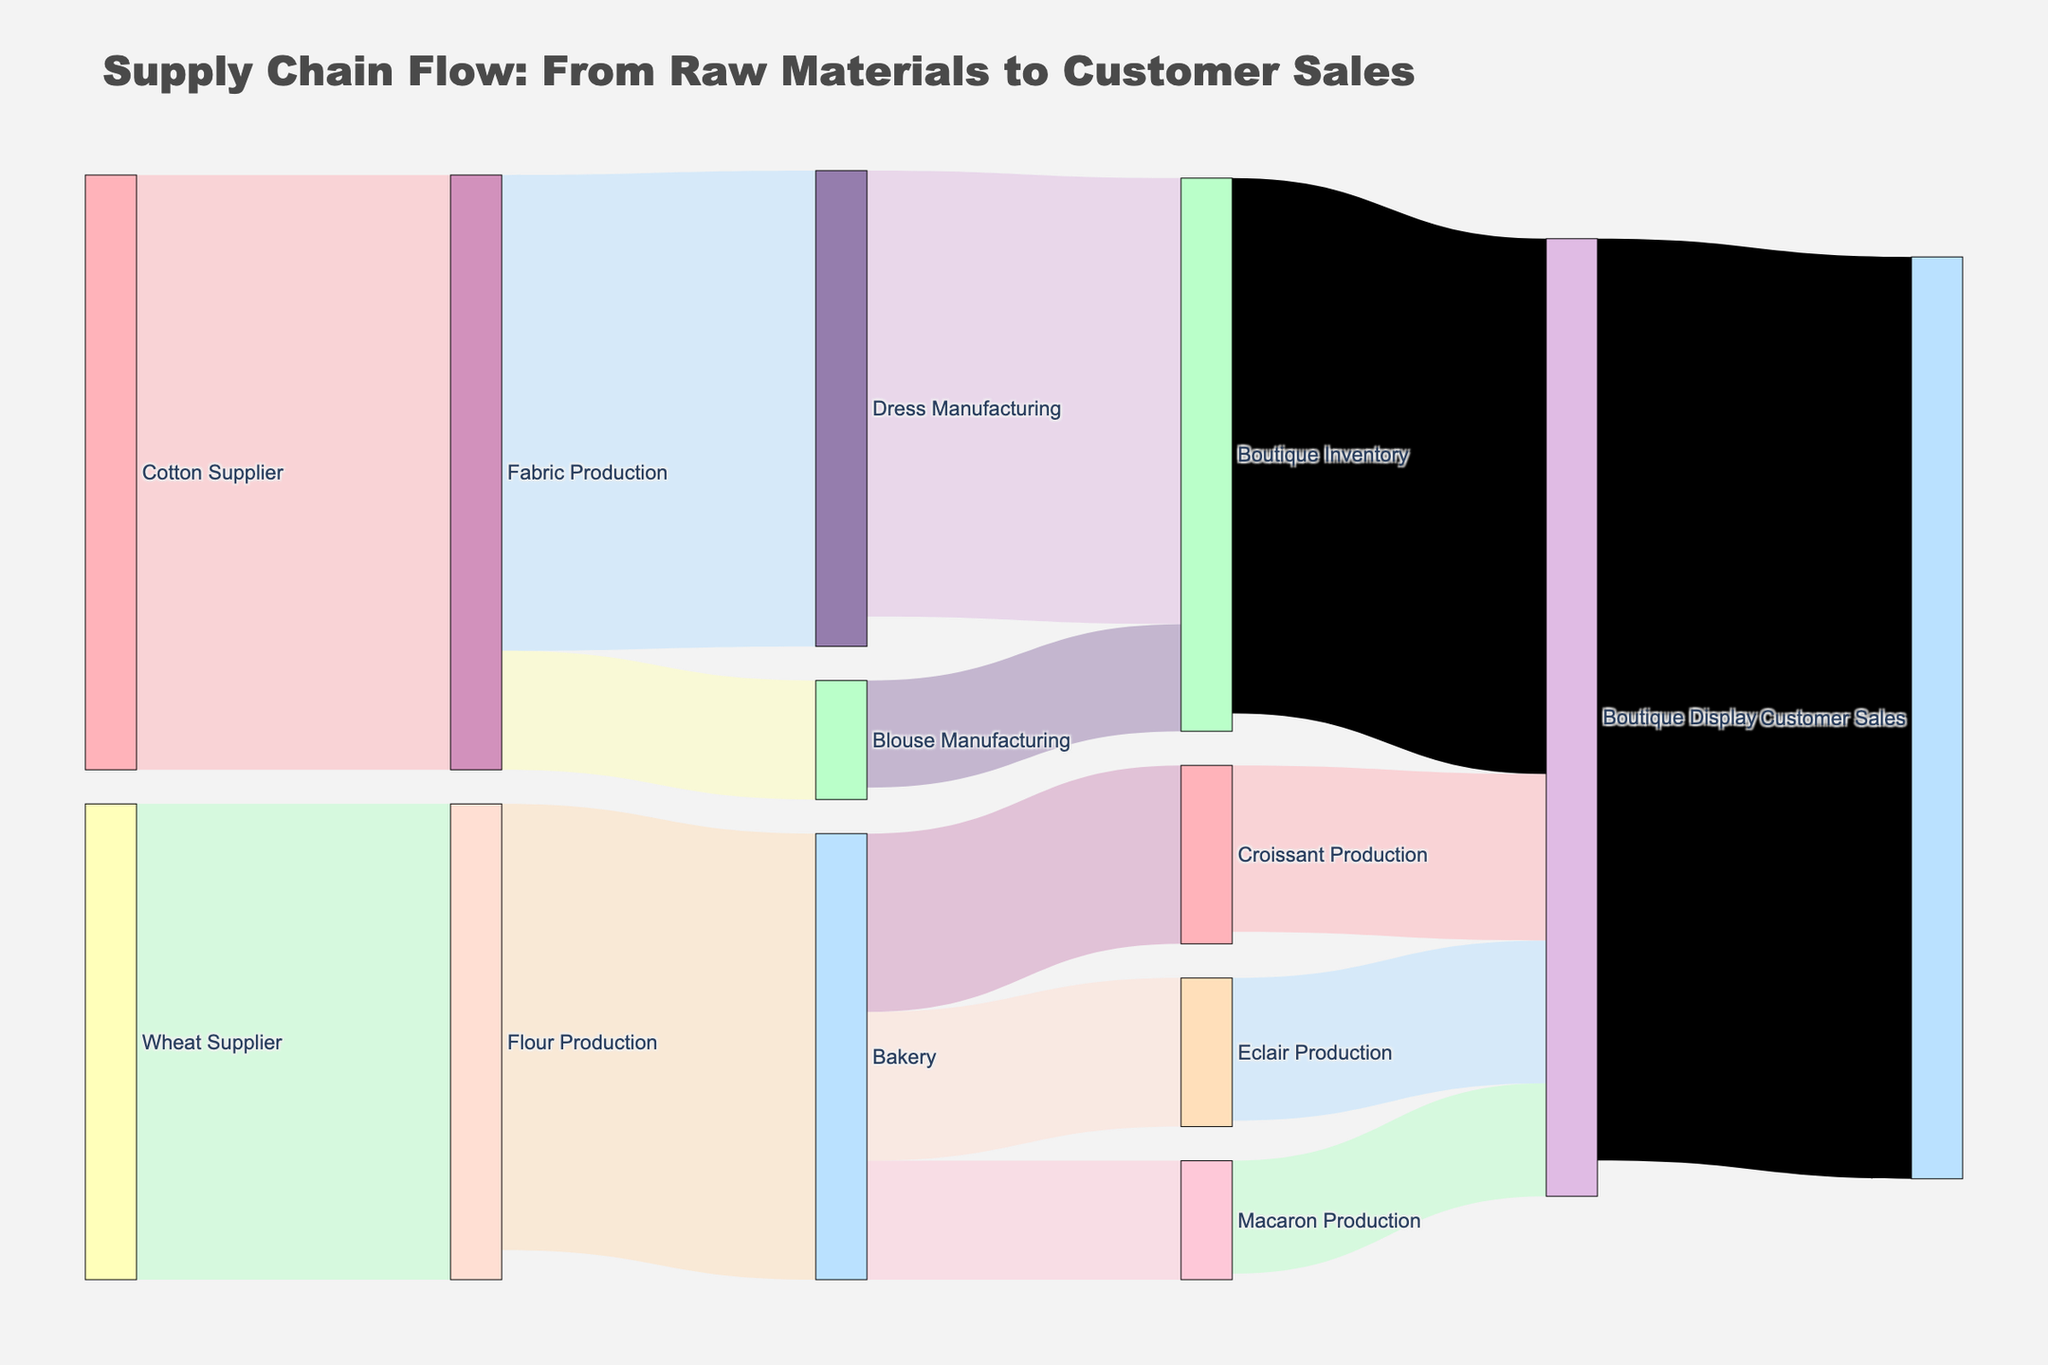What is the total flow from Fabric Production to Dress Manufacturing? The diagram shows a flow between Fabric Production and Dress Manufacturing labeled with a value. By looking at this label, we can identify the total flow from Fabric Production to Dress Manufacturing.
Answer: 800 How much of the bakery's flour production goes into croissant production? The Sankey diagram depicts flows from Flour Production to different bakery products. The flow directly leading to Croissant Production is labeled with the respective value.
Answer: 300 Which category contributes more to the Boutique Display: fashion items or pastries? To determine this, sum the flows from Boutique Inventory to Boutique Display for fashion items and from different bakery product productions to Boutique Display for pastries. Compare these totals.
Answer: Pastries How much flow does the Wheat Supplier contribute directly or indirectly to the Customer Sales? Wheat Supplier contributes to Flour Production. From Flour Production, the flow is divided into different bakery items production which eventually contributes to Customer Sales. Sum the values attributed to the Wheat Supplier's downstream flows that lead into Customer Sales.
Answer: 750 What is the combined total value for Croissant, Macaron, and Eclair production? The diagram shows individual flows for Croissant Production, Macaron Production, and Eclair Production. Sum these values: Croissant Production (300), Macaron Production (200), and Eclair Production (250.).
Answer: 750 Which supplier has a greater impact on Customer Sales: Cotton Supplier or Wheat Supplier? Analyze the flows starting from Cotton Supplier and Wheat Supplier and trace these downstream to Customer Sales. Sum the total resulting flows that eventually reach Customer Sales for each supplier and compare.
Answer: Cotton Supplier If we consider only Dress Manufacturing and Blouse Manufacturing, what is the total flow from Fabric Production to Customer Sales? Add the flows from Fabric Production to Dress Manufacturing (800) and Blouse Manufacturing (200). Then trace these flows to Customer Sales to ascertain their impact. From Dress Manufacturing (750) and Blouse Manufacturing (180) to Boutique Inventory, and then to Boutique Display (total 930). Summing total flows of these paths.
Answer: 930 What percentage of Dress Manufacturing's output ends up in the Boutique Inventory? The flow from Dress Manufacturing to Boutique Inventory is represented in the diagram. Calculate its proportion out of Dress Manufacturing's total output.
Answer: 93.75% How many units of products (both pastries and fashion items) are displayed in the Boutique Display? Combine the flows that aggregate to Boutique Display: product flows stemming from both the Boutique Inventory and direct bakery product outputs to Boutique Display as shown in the diagram. Add all the values leading to Boutique Display.
Answer: 1610 